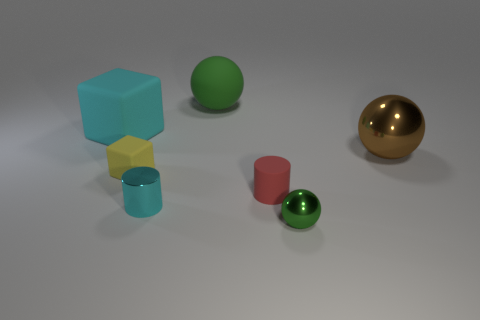How many green spheres must be subtracted to get 1 green spheres? 1 Subtract all cylinders. How many objects are left? 5 Subtract 1 cylinders. How many cylinders are left? 1 Subtract all cyan balls. Subtract all yellow cylinders. How many balls are left? 3 Subtract all green balls. How many cyan cubes are left? 1 Subtract all big yellow rubber balls. Subtract all yellow rubber objects. How many objects are left? 6 Add 7 cyan cylinders. How many cyan cylinders are left? 8 Add 1 cyan metal things. How many cyan metal things exist? 2 Add 1 tiny green metallic objects. How many objects exist? 8 Subtract all cyan blocks. How many blocks are left? 1 